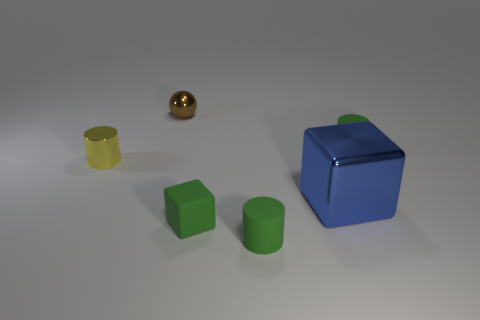Are there any other things that have the same size as the blue metal object?
Make the answer very short. No. Do the green thing in front of the green rubber block and the tiny green thing behind the yellow shiny cylinder have the same material?
Ensure brevity in your answer.  Yes. There is another shiny object that is the same size as the brown thing; what shape is it?
Ensure brevity in your answer.  Cylinder. Is there a tiny brown metal object that has the same shape as the big thing?
Your response must be concise. No. There is a tiny matte thing that is behind the small yellow cylinder; is its color the same as the small rubber cylinder in front of the tiny green cube?
Give a very brief answer. Yes. Are there any small metallic objects in front of the small brown metallic object?
Offer a very short reply. Yes. The small cylinder that is both to the left of the shiny block and behind the large blue metal object is made of what material?
Make the answer very short. Metal. Does the tiny cylinder to the right of the large blue object have the same material as the tiny green block?
Offer a very short reply. Yes. What is the yellow object made of?
Give a very brief answer. Metal. How big is the block that is on the right side of the tiny green cube?
Your answer should be very brief. Large. 